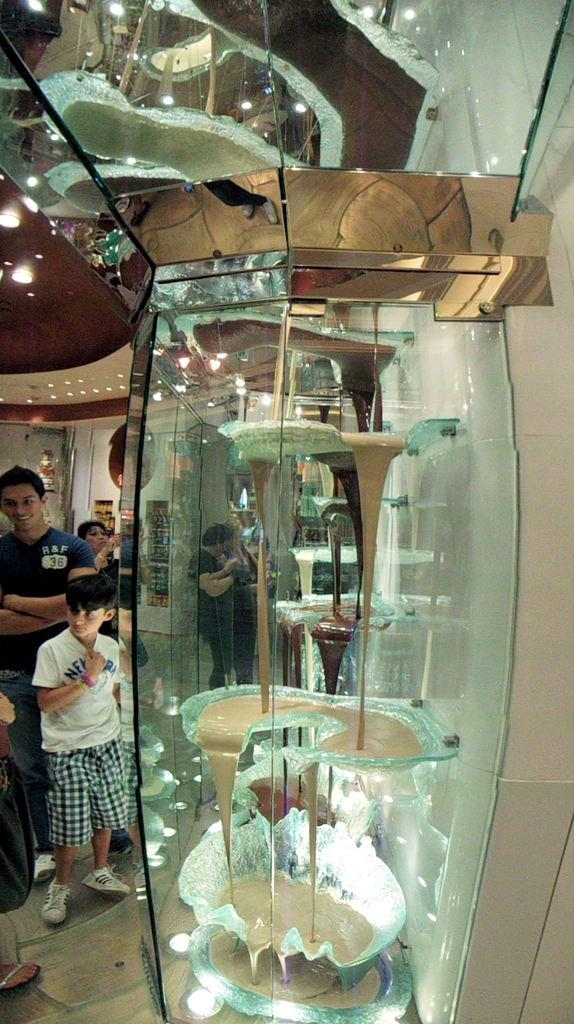Where was the image taken? The image was taken inside a room. What is located in the middle of the room? There is glass in the middle of the room. Are there any people visible in the image? Yes, there are persons on the left side of the room. What type of lighting is present in the room? There are lights at the top of the room. What is the chance of seeing an airplane inside the room in the image? There is no airplane present in the image, so it is not possible to determine the chance of seeing one. 